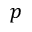<formula> <loc_0><loc_0><loc_500><loc_500>p</formula> 